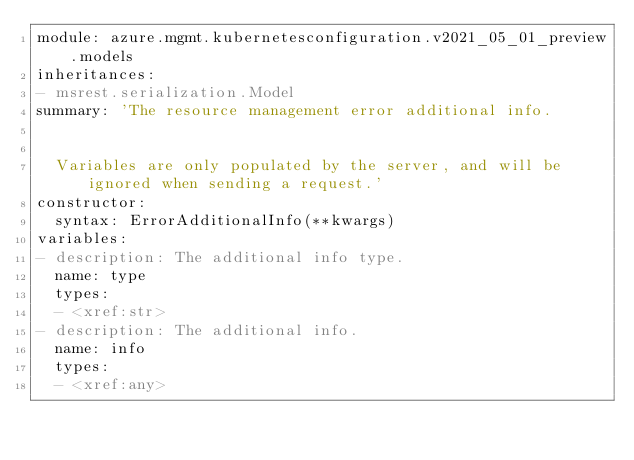<code> <loc_0><loc_0><loc_500><loc_500><_YAML_>module: azure.mgmt.kubernetesconfiguration.v2021_05_01_preview.models
inheritances:
- msrest.serialization.Model
summary: 'The resource management error additional info.


  Variables are only populated by the server, and will be ignored when sending a request.'
constructor:
  syntax: ErrorAdditionalInfo(**kwargs)
variables:
- description: The additional info type.
  name: type
  types:
  - <xref:str>
- description: The additional info.
  name: info
  types:
  - <xref:any>
</code> 